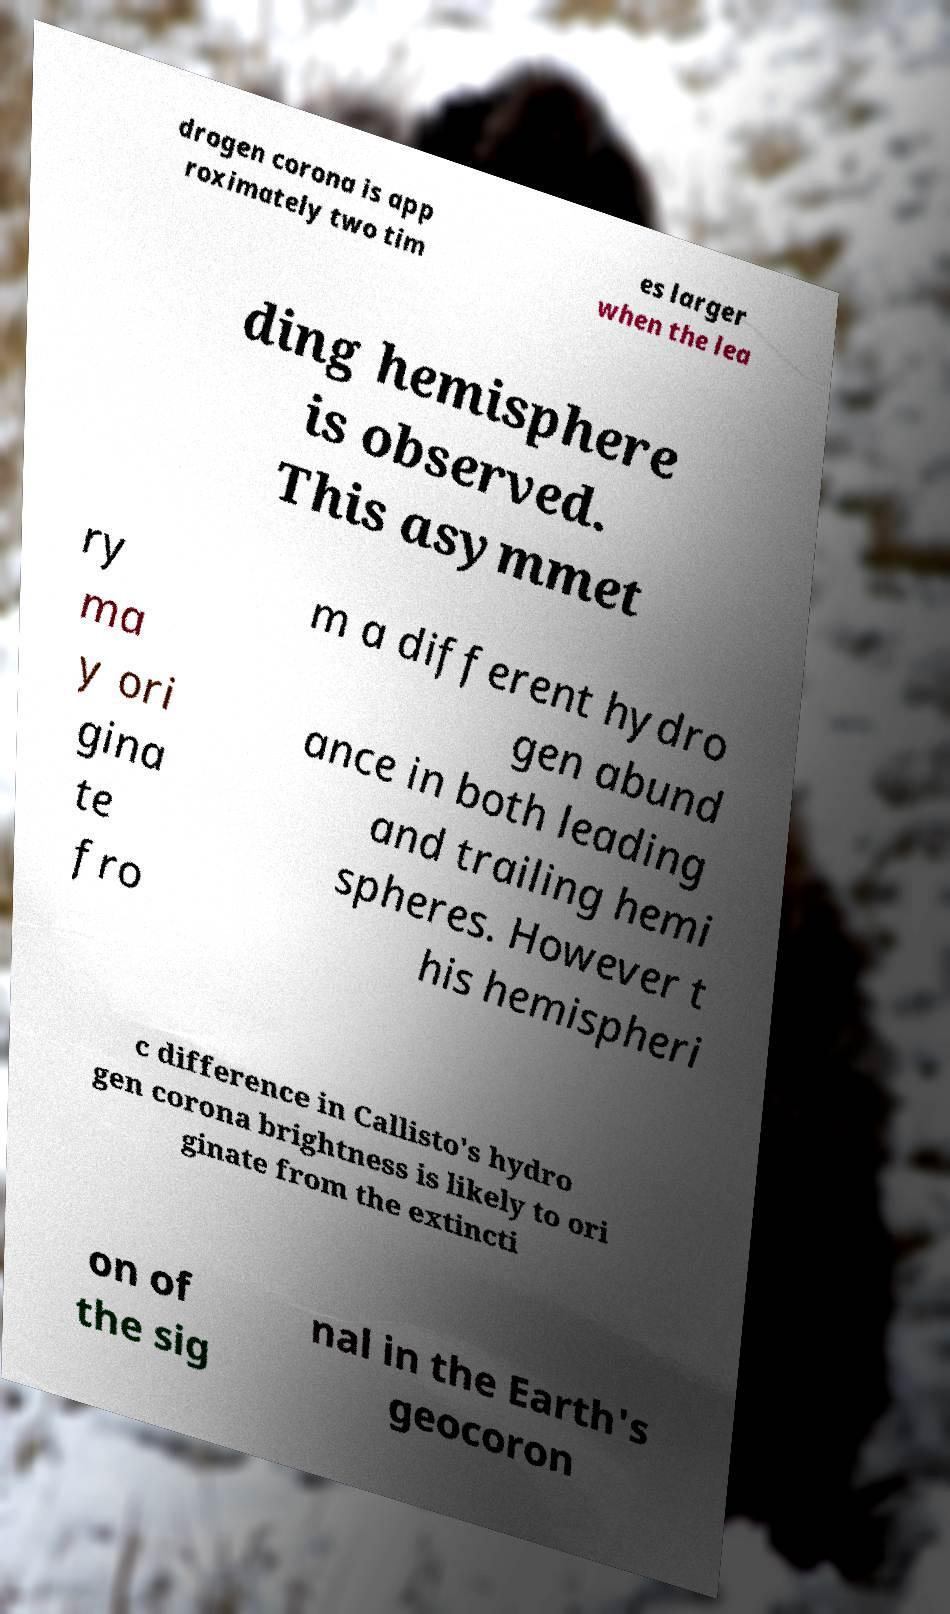Can you accurately transcribe the text from the provided image for me? drogen corona is app roximately two tim es larger when the lea ding hemisphere is observed. This asymmet ry ma y ori gina te fro m a different hydro gen abund ance in both leading and trailing hemi spheres. However t his hemispheri c difference in Callisto's hydro gen corona brightness is likely to ori ginate from the extincti on of the sig nal in the Earth's geocoron 